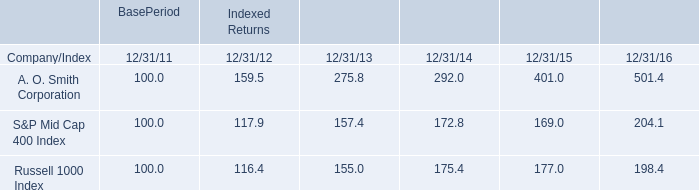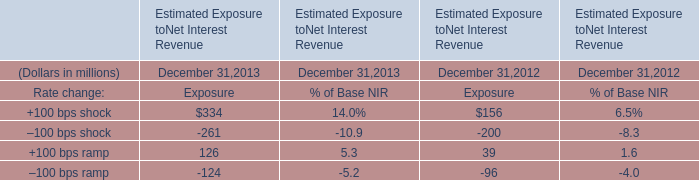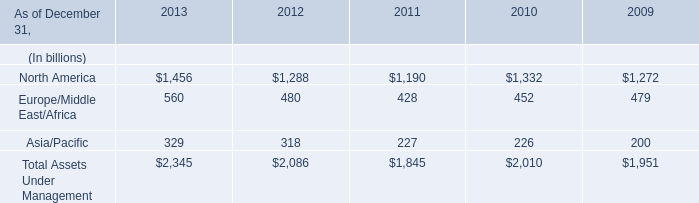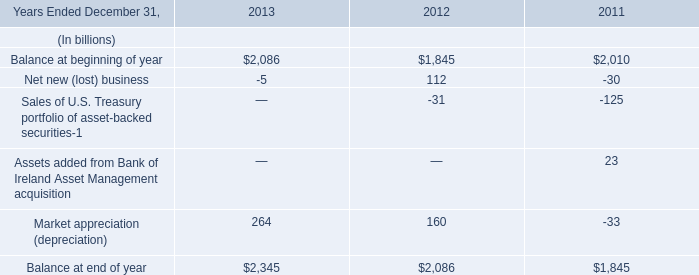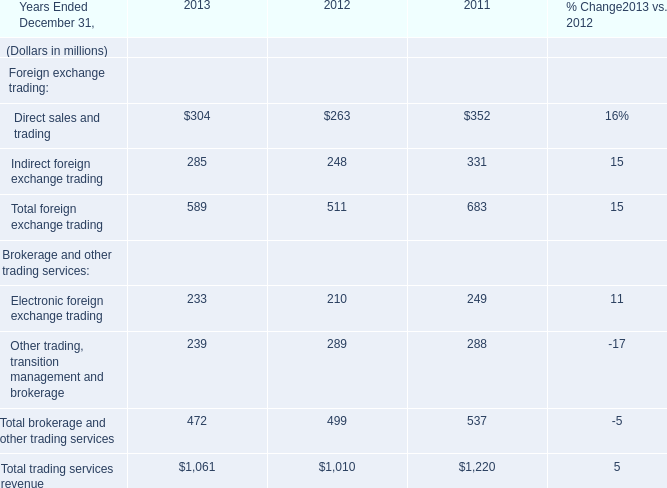What will Balance at beginning of year be like in 2014 Ended December 31,2014 if it develops with the same increasing rate as in 2013 Ended December 31,2013? (in billion) 
Computations: (2086 * (1 + ((2086 - 1845) / 1845)))
Answer: 2358.48022. 